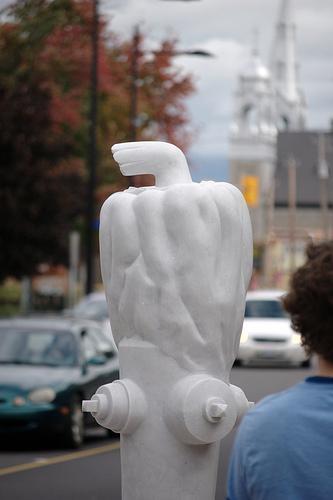How many statues are there?
Give a very brief answer. 1. 